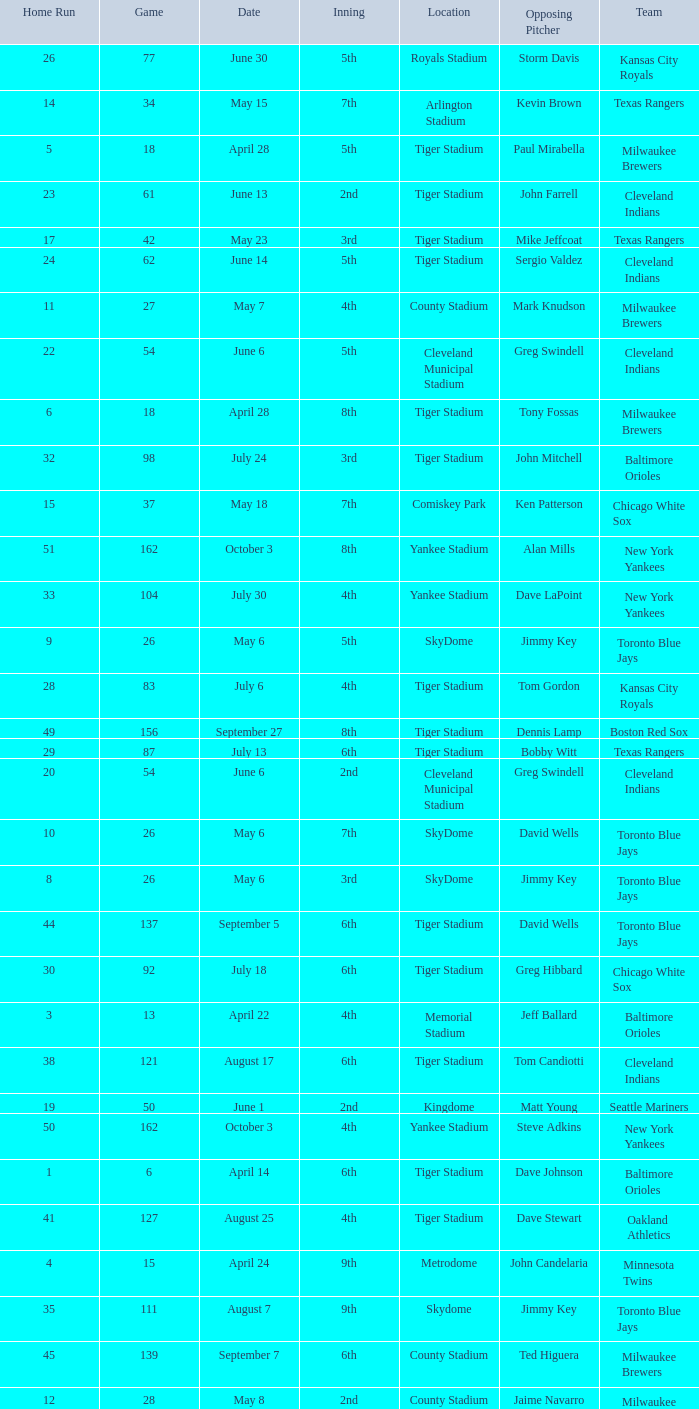On June 17 in Tiger stadium, what was the average home run? 25.0. 